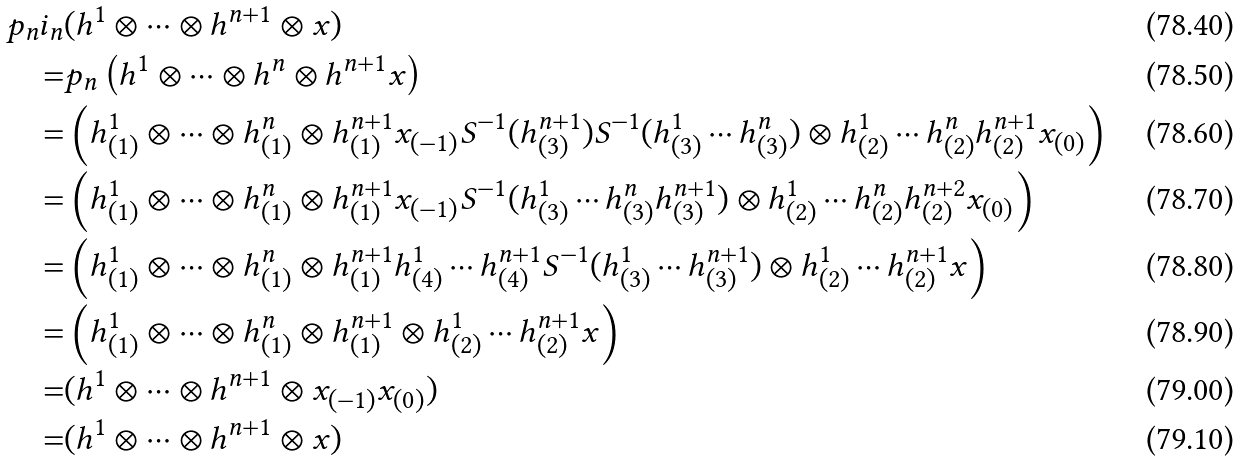Convert formula to latex. <formula><loc_0><loc_0><loc_500><loc_500>p _ { n } i _ { n } & ( h ^ { 1 } \otimes \cdots \otimes h ^ { n + 1 } \otimes x ) \\ = & p _ { n } \left ( h ^ { 1 } \otimes \cdots \otimes h ^ { n } \otimes h ^ { n + 1 } x \right ) \\ = & \left ( h ^ { 1 } _ { ( 1 ) } \otimes \cdots \otimes h ^ { n } _ { ( 1 ) } \otimes h ^ { n + 1 } _ { ( 1 ) } x _ { ( - 1 ) } S ^ { - 1 } ( h ^ { n + 1 } _ { ( 3 ) } ) S ^ { - 1 } ( h ^ { 1 } _ { ( 3 ) } \cdots h ^ { n } _ { ( 3 ) } ) \otimes h ^ { 1 } _ { ( 2 ) } \cdots h ^ { n } _ { ( 2 ) } h ^ { n + 1 } _ { ( 2 ) } x _ { ( 0 ) } \right ) \\ = & \left ( h ^ { 1 } _ { ( 1 ) } \otimes \cdots \otimes h ^ { n } _ { ( 1 ) } \otimes h ^ { n + 1 } _ { ( 1 ) } x _ { ( - 1 ) } S ^ { - 1 } ( h ^ { 1 } _ { ( 3 ) } \cdots h ^ { n } _ { ( 3 ) } h ^ { n + 1 } _ { ( 3 ) } ) \otimes h ^ { 1 } _ { ( 2 ) } \cdots h ^ { n } _ { ( 2 ) } h ^ { n + 2 } _ { ( 2 ) } x _ { ( 0 ) } \right ) \\ = & \left ( h ^ { 1 } _ { ( 1 ) } \otimes \cdots \otimes h ^ { n } _ { ( 1 ) } \otimes h ^ { n + 1 } _ { ( 1 ) } h ^ { 1 } _ { ( 4 ) } \cdots h ^ { n + 1 } _ { ( 4 ) } S ^ { - 1 } ( h ^ { 1 } _ { ( 3 ) } \cdots h ^ { n + 1 } _ { ( 3 ) } ) \otimes h ^ { 1 } _ { ( 2 ) } \cdots h ^ { n + 1 } _ { ( 2 ) } x \right ) \\ = & \left ( h ^ { 1 } _ { ( 1 ) } \otimes \cdots \otimes h ^ { n } _ { ( 1 ) } \otimes h ^ { n + 1 } _ { ( 1 ) } \otimes h ^ { 1 } _ { ( 2 ) } \cdots h ^ { n + 1 } _ { ( 2 ) } x \right ) \\ = & ( h ^ { 1 } \otimes \cdots \otimes h ^ { n + 1 } \otimes x _ { ( - 1 ) } x _ { ( 0 ) } ) \\ = & ( h ^ { 1 } \otimes \cdots \otimes h ^ { n + 1 } \otimes x )</formula> 